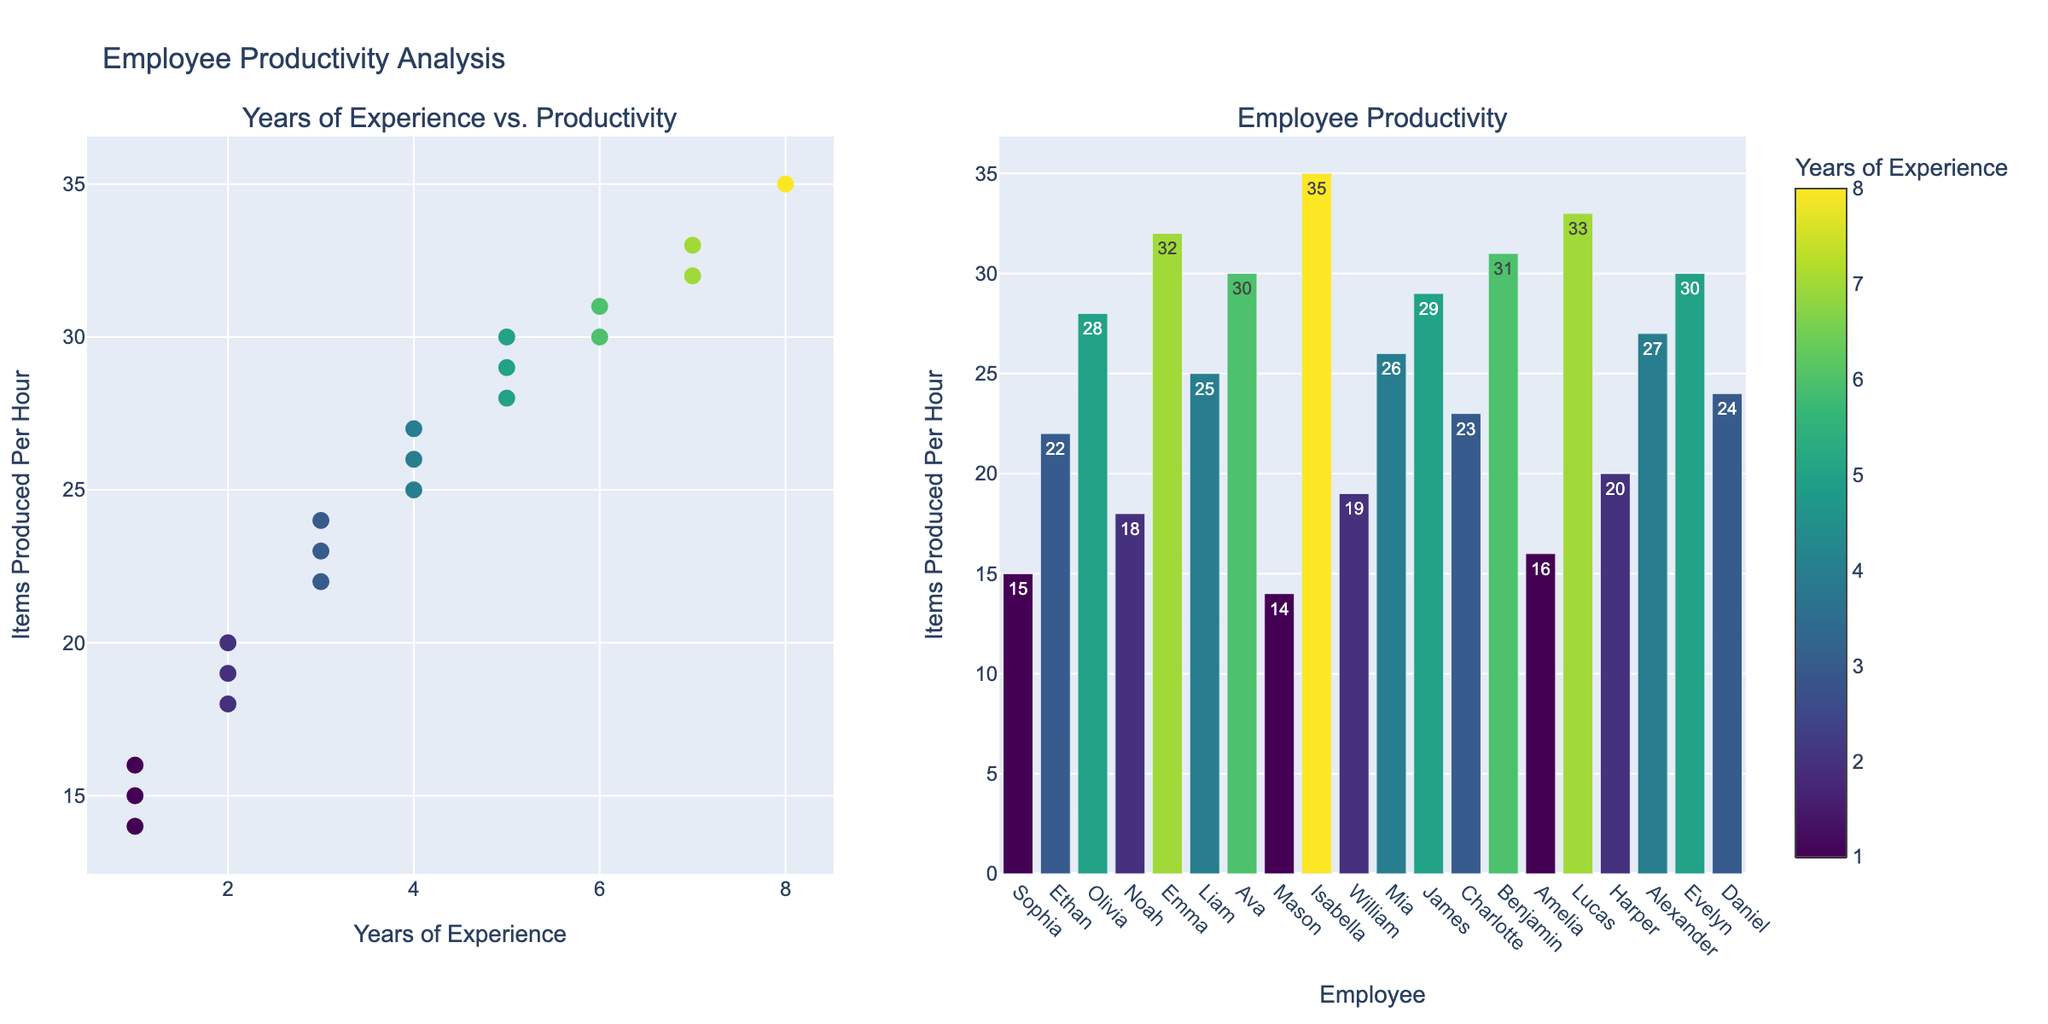Which employee has the highest productivity? The bar plot shows "Items Produced Per Hour" for each employee. The tallest bar represents Isabella, whose productivity is the highest.
Answer: Isabella What is the range of years of experience among the employees? The scatter plot shows "Years of Experience" on the x-axis. The minimum value is 1 year and the maximum value is 8 years. Therefore, the range is 8 - 1 = 7 years.
Answer: 7 years Are there any employees with the same years of experience but different productivity levels? By examining the scatter plot, we can see that multiple employees share the same 'Years of Experience' but have different 'Items Produced Per Hour' values. For example, Ethan and Charlotte both have 3 years of experience (Ethan with 22 and Charlotte with 23 items produced per hour).
Answer: Yes Which employee has the highest productivity among those with exactly 5 years of experience? The scatter plot allows us to identify employees with 5 years of experience. James and Olivia both have 5 years of experience. James produces 29 items per hour, while Olivia produces 28. Evelyn, with 5 years, produces 30. Hence, Evelyn has the highest productivity among these employees.
Answer: Evelyn How does productivity generally correlate with years of experience? By examining the scatter plot, we can see that as the number of years of experience increases, there is a general trend that productivity also increases. The points in the scatter plot generally follow a positive trend.
Answer: Positive correlation Compare the productivity of employees with 1 year of experience to those with 4 years of experience. From the scatter plot and the bar plot, we see that employees with 1 year of experience (Sophia, Mason, Amelia) produce 15, 14, and 16 items per hour, respectively. Employees with 4 years of experience (Liam, Mia, Alexander) produce 25, 26, and 27 items per hour, respectively. Thus, employees with 4 years of experience generally produce more items per hour compared to those with 1 year.
Answer: 4 years more productive What is the average productivity of employees with more than 5 years of experience? From the scatter plot and bar plot, we identify employees with more than 5 years of experience (Emma, Ava, Isabella, Lucas, Benjamin). Their productivities are 32, 30, 35, 33, and 31. The average productivity is calculated as (32 + 30 + 35 + 33 + 31) / 5 = 32.2 items per hour.
Answer: 32.2 items per hour Who are the employees with the least productivity, and what are their experience levels? The bar plot shows the shortest bars corresponding to Mason and Sophia, who both have 1 year of experience and produce 14 and 15 items per hour, respectively.
Answer: Mason and Sophia, 1 year What is the total productivity of all employees combined? To find the total productivity, sum all the "Items Produced Per Hour" values from the bar plot: 15 + 22 + 28 + 18 + 32 + 25 + 30 + 14 + 35 + 19 + 26 + 29 + 23 + 31 + 16 + 33 + 20 + 27 + 30 = 423. Therefore, the total productivity is 423 items per hour.
Answer: 423 items per hour What is the difference in productivity between the most experienced and least experienced employees? From the scatter plot, the most experienced employee is Isabella with 8 years of experience and a productivity of 35 items per hour. The least experienced employees (1 year of experience) are Mason, Sophia, and Amelia with 14, 15, and 16 items per hour, respectively. The largest difference is 35 - 14 = 21 items per hour.
Answer: 21 items per hour 